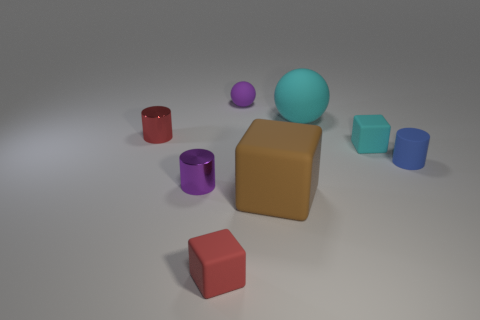What number of other things are there of the same shape as the small purple matte object?
Make the answer very short. 1. Is the material of the cyan cube that is behind the small purple metallic object the same as the cyan sphere?
Provide a short and direct response. Yes. What number of objects are either small green rubber cylinders or large cyan spheres?
Offer a very short reply. 1. There is a purple object that is the same shape as the blue rubber thing; what is its size?
Your response must be concise. Small. The red shiny cylinder is what size?
Provide a succinct answer. Small. Are there more matte spheres on the right side of the brown block than matte cylinders?
Your response must be concise. No. Are there any other things that have the same material as the big sphere?
Offer a very short reply. Yes. Do the tiny object behind the tiny red metallic cylinder and the small cylinder that is right of the red cube have the same color?
Give a very brief answer. No. What material is the purple thing that is left of the tiny red object that is to the right of the red thing that is to the left of the tiny purple metal cylinder?
Ensure brevity in your answer.  Metal. Is the number of small matte things greater than the number of large gray things?
Provide a succinct answer. Yes. 